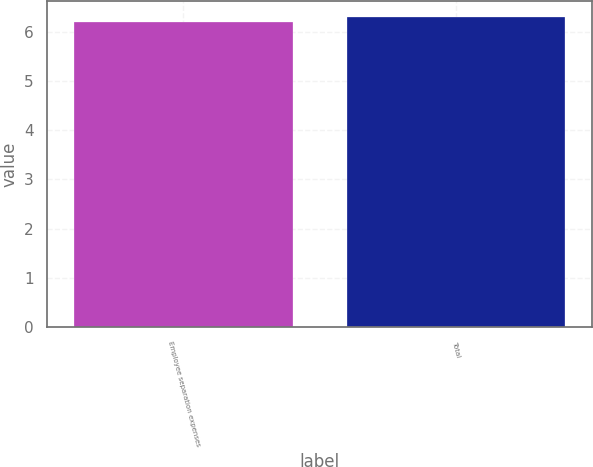Convert chart. <chart><loc_0><loc_0><loc_500><loc_500><bar_chart><fcel>Employee separation expenses<fcel>Total<nl><fcel>6.2<fcel>6.3<nl></chart> 